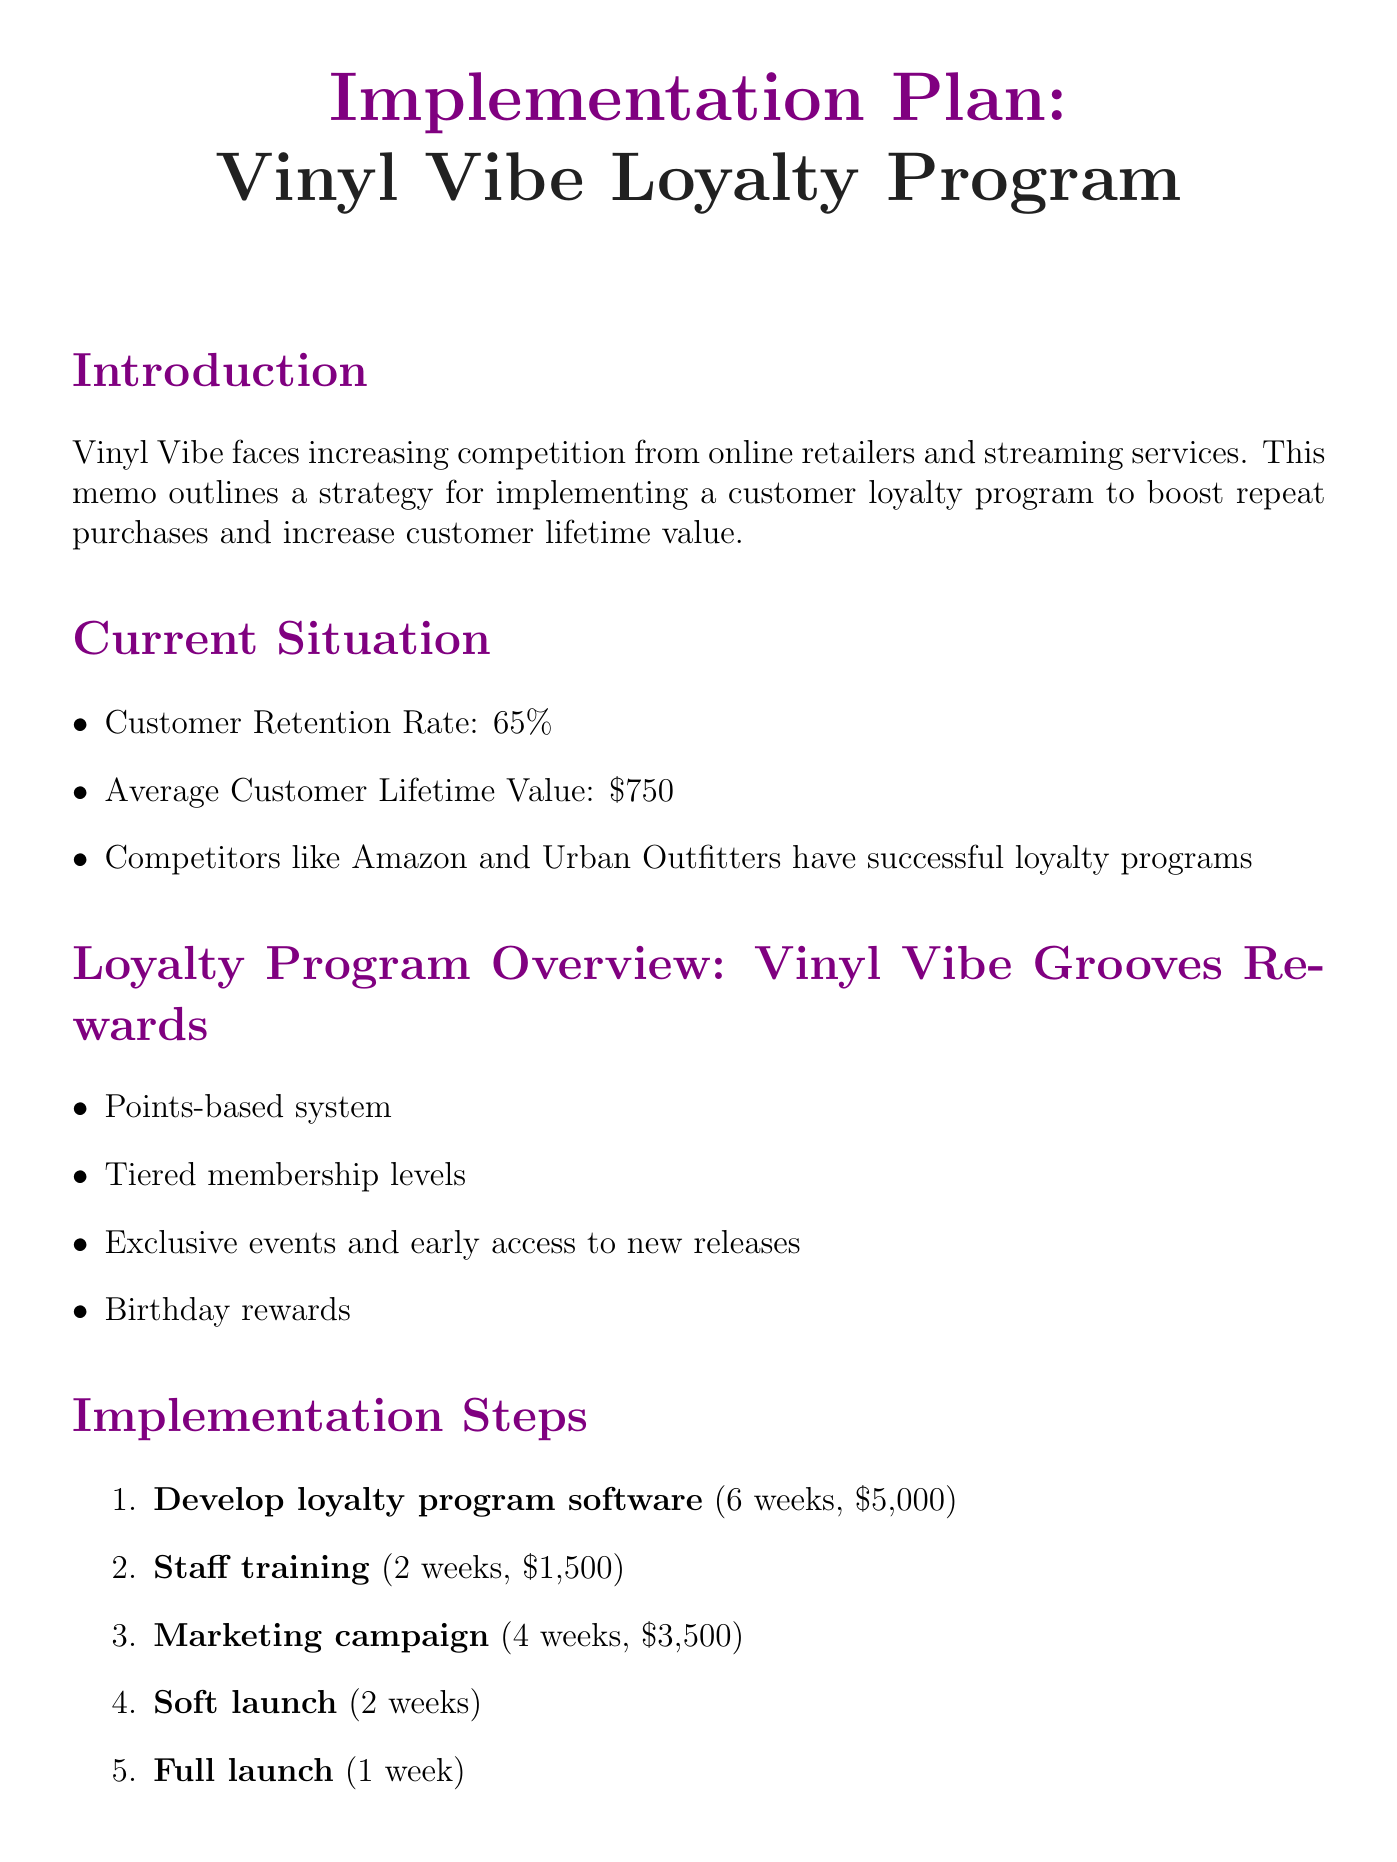What is the title of the memo? The title of the memo is explicitly stated at the top of the document.
Answer: Implementation Plan: Vinyl Vibe Loyalty Program What is the average customer lifetime value? The average customer lifetime value is mentioned in the current situation section.
Answer: $750 Which company is providing the loyalty program software? The provider of the software is noted in the implementation steps under software development.
Answer: Loyaltron What is the timeline for the full launch? The full launch timeline is specified in the implementation steps.
Answer: 1 week What is the projected increase in customer retention within the first year? The projected increase is detailed in the projected outcomes section.
Answer: 15% What is the total estimated cost for the loyalty program implementation? The total estimated cost is summarized in the budget overview.
Answer: $15,000 What are the key performance indicators being monitored? The key performance indicators are listed in the monitoring and evaluation section.
Answer: Program enrollment rate, Repeat purchase frequency, Average transaction value, Customer satisfaction scores What is the goal for program enrollment within six months? The goal for program enrollment is outlined in the projected outcomes.
Answer: 50% of customers What is the first step in the implementation plan? The first step is highlighted in the implementation steps section.
Answer: Develop loyalty program software 